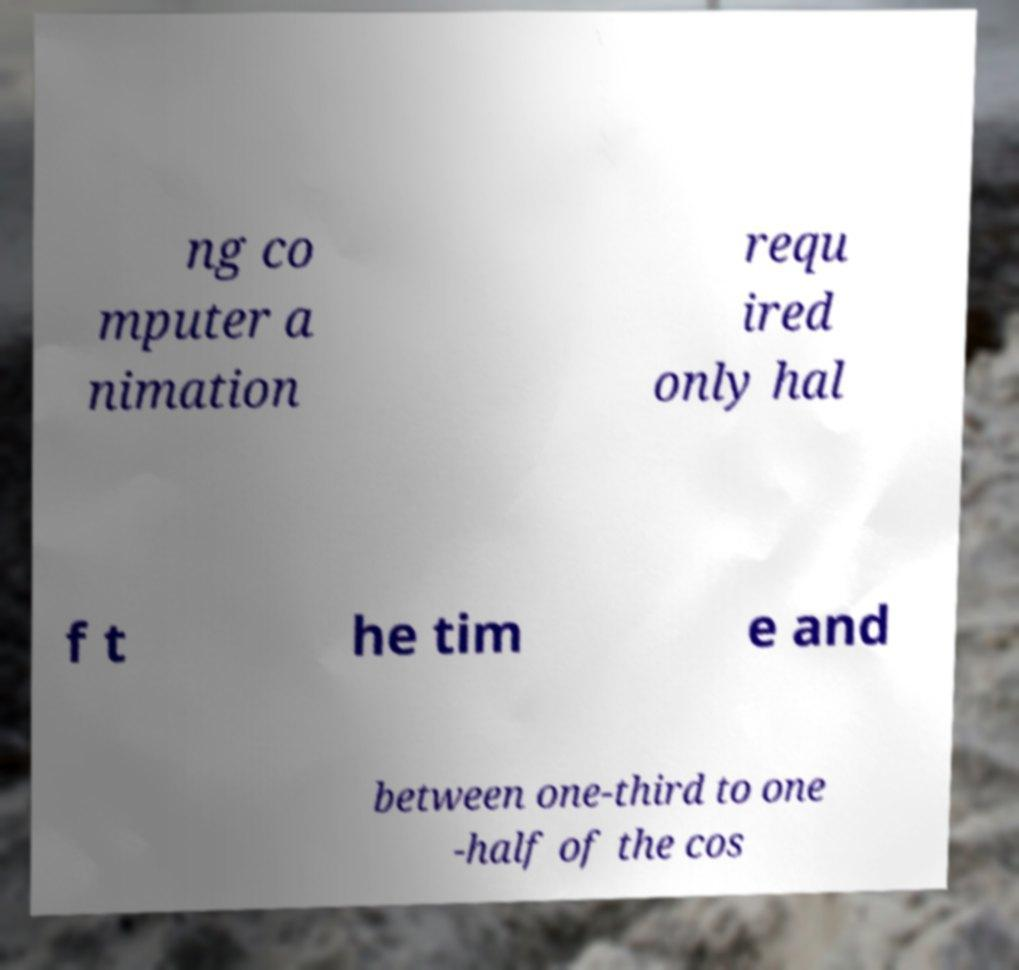What messages or text are displayed in this image? I need them in a readable, typed format. ng co mputer a nimation requ ired only hal f t he tim e and between one-third to one -half of the cos 